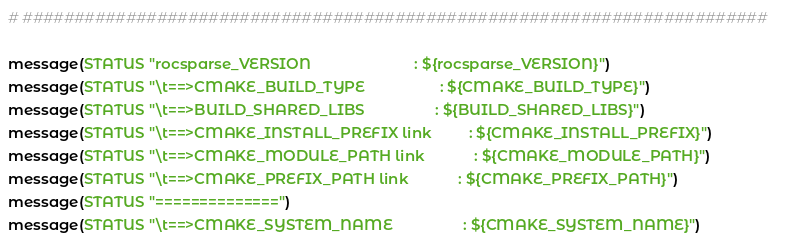<code> <loc_0><loc_0><loc_500><loc_500><_CMake_># ########################################################################

message(STATUS "rocsparse_VERSION                         : ${rocsparse_VERSION}")
message(STATUS "\t==>CMAKE_BUILD_TYPE                  : ${CMAKE_BUILD_TYPE}")
message(STATUS "\t==>BUILD_SHARED_LIBS                 : ${BUILD_SHARED_LIBS}")
message(STATUS "\t==>CMAKE_INSTALL_PREFIX link         : ${CMAKE_INSTALL_PREFIX}")
message(STATUS "\t==>CMAKE_MODULE_PATH link            : ${CMAKE_MODULE_PATH}")
message(STATUS "\t==>CMAKE_PREFIX_PATH link            : ${CMAKE_PREFIX_PATH}")
message(STATUS "==============")
message(STATUS "\t==>CMAKE_SYSTEM_NAME                 : ${CMAKE_SYSTEM_NAME}")</code> 